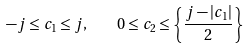<formula> <loc_0><loc_0><loc_500><loc_500>- j \leq c _ { 1 } \leq j , \quad 0 \leq c _ { 2 } \leq \left \{ \frac { j - | c _ { 1 } | } { 2 } \right \}</formula> 